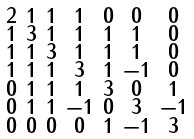Convert formula to latex. <formula><loc_0><loc_0><loc_500><loc_500>\begin{smallmatrix} 2 & 1 & 1 & 1 & 0 & 0 & 0 \\ 1 & 3 & 1 & 1 & 1 & 1 & 0 \\ 1 & 1 & 3 & 1 & 1 & 1 & 0 \\ 1 & 1 & 1 & 3 & 1 & - 1 & 0 \\ 0 & 1 & 1 & 1 & 3 & 0 & 1 \\ 0 & 1 & 1 & - 1 & 0 & 3 & - 1 \\ 0 & 0 & 0 & 0 & 1 & - 1 & 3 \end{smallmatrix}</formula> 